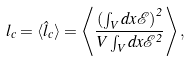Convert formula to latex. <formula><loc_0><loc_0><loc_500><loc_500>l _ { c } = \langle \hat { l } _ { c } \rangle = \left \langle \frac { \left ( \int _ { V } d x \mathcal { E } \right ) ^ { 2 } } { V \int _ { V } d x \mathcal { E } ^ { 2 } } \right \rangle ,</formula> 